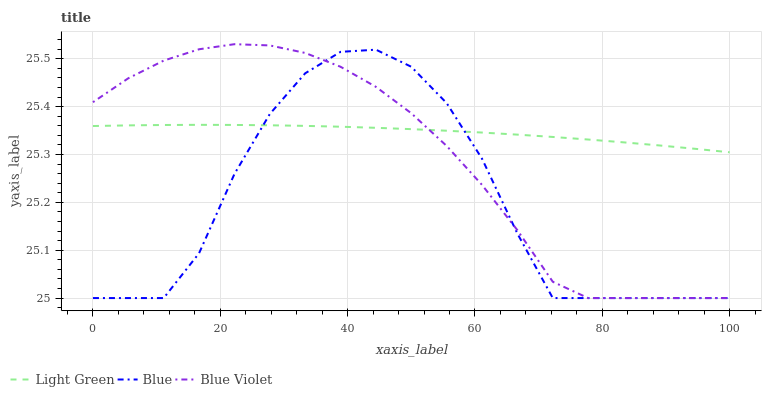Does Blue have the minimum area under the curve?
Answer yes or no. Yes. Does Blue Violet have the minimum area under the curve?
Answer yes or no. No. Does Blue Violet have the maximum area under the curve?
Answer yes or no. No. Is Blue the roughest?
Answer yes or no. Yes. Is Blue Violet the smoothest?
Answer yes or no. No. Is Blue Violet the roughest?
Answer yes or no. No. Does Light Green have the lowest value?
Answer yes or no. No. Does Light Green have the highest value?
Answer yes or no. No. 